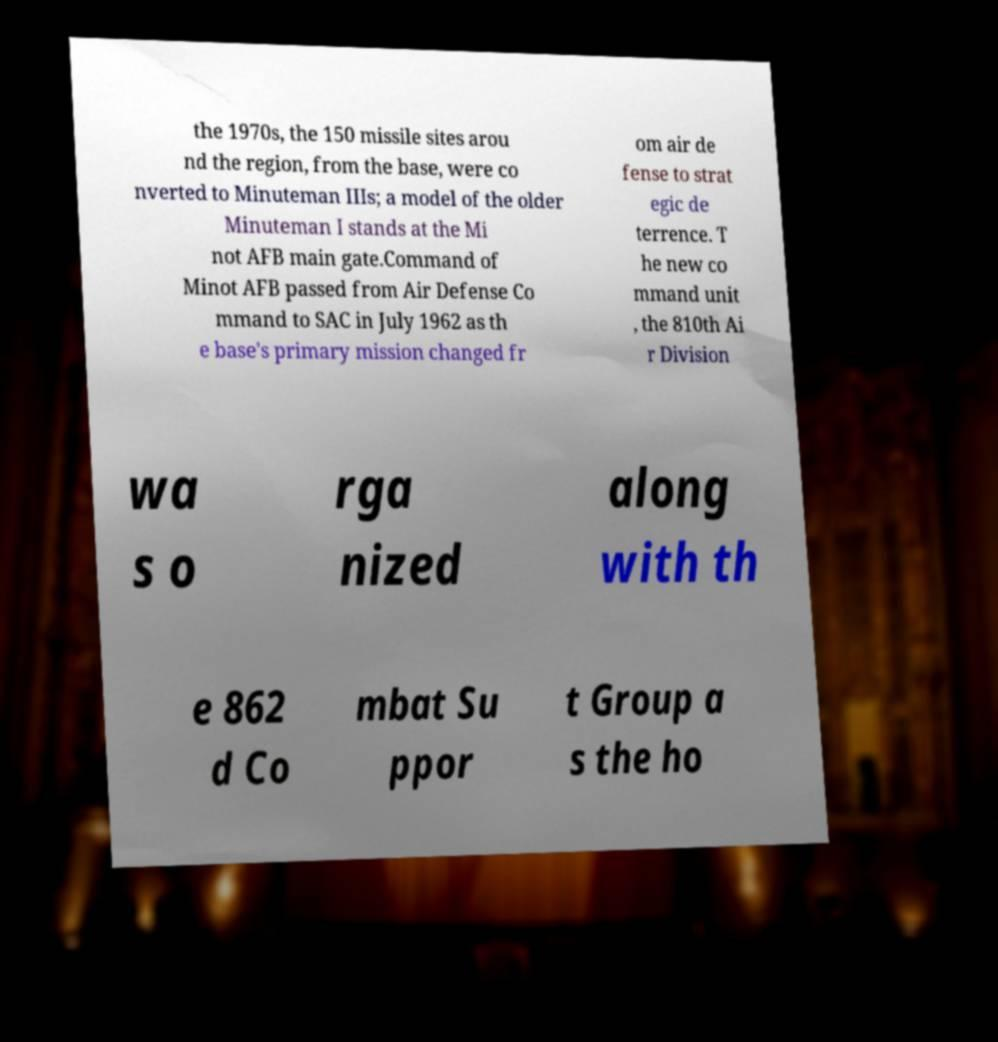Could you assist in decoding the text presented in this image and type it out clearly? the 1970s, the 150 missile sites arou nd the region, from the base, were co nverted to Minuteman IIIs; a model of the older Minuteman I stands at the Mi not AFB main gate.Command of Minot AFB passed from Air Defense Co mmand to SAC in July 1962 as th e base's primary mission changed fr om air de fense to strat egic de terrence. T he new co mmand unit , the 810th Ai r Division wa s o rga nized along with th e 862 d Co mbat Su ppor t Group a s the ho 